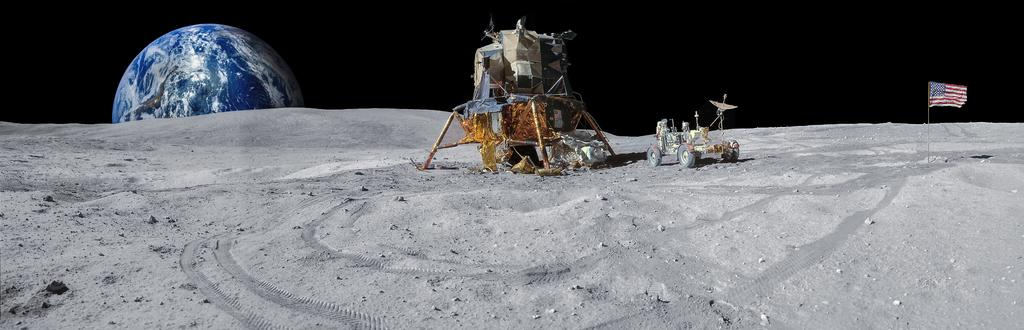Where was the image likely taken? The image appears to be taken on Mars. What is the main object in the front of the image? There is a vehicle in the front of the image. What can be seen on the right side of the image? There is a flag on the right side of the image. What is located on the left side of the image? There is a globe on the left side of the image. What type of terrain is visible at the bottom of the image? There is sand at the bottom of the image. What type of muscle can be seen flexing in the image? There is no muscle visible in the image; it is a landscape scene on Mars. 